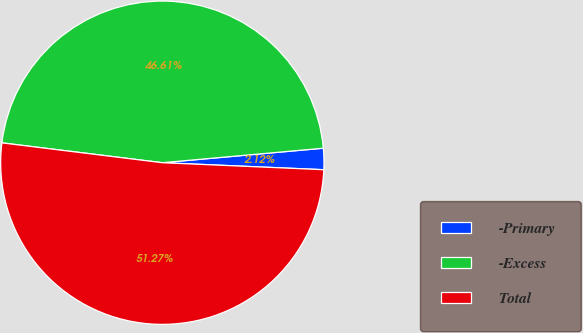Convert chart. <chart><loc_0><loc_0><loc_500><loc_500><pie_chart><fcel>-Primary<fcel>-Excess<fcel>Total<nl><fcel>2.12%<fcel>46.61%<fcel>51.27%<nl></chart> 